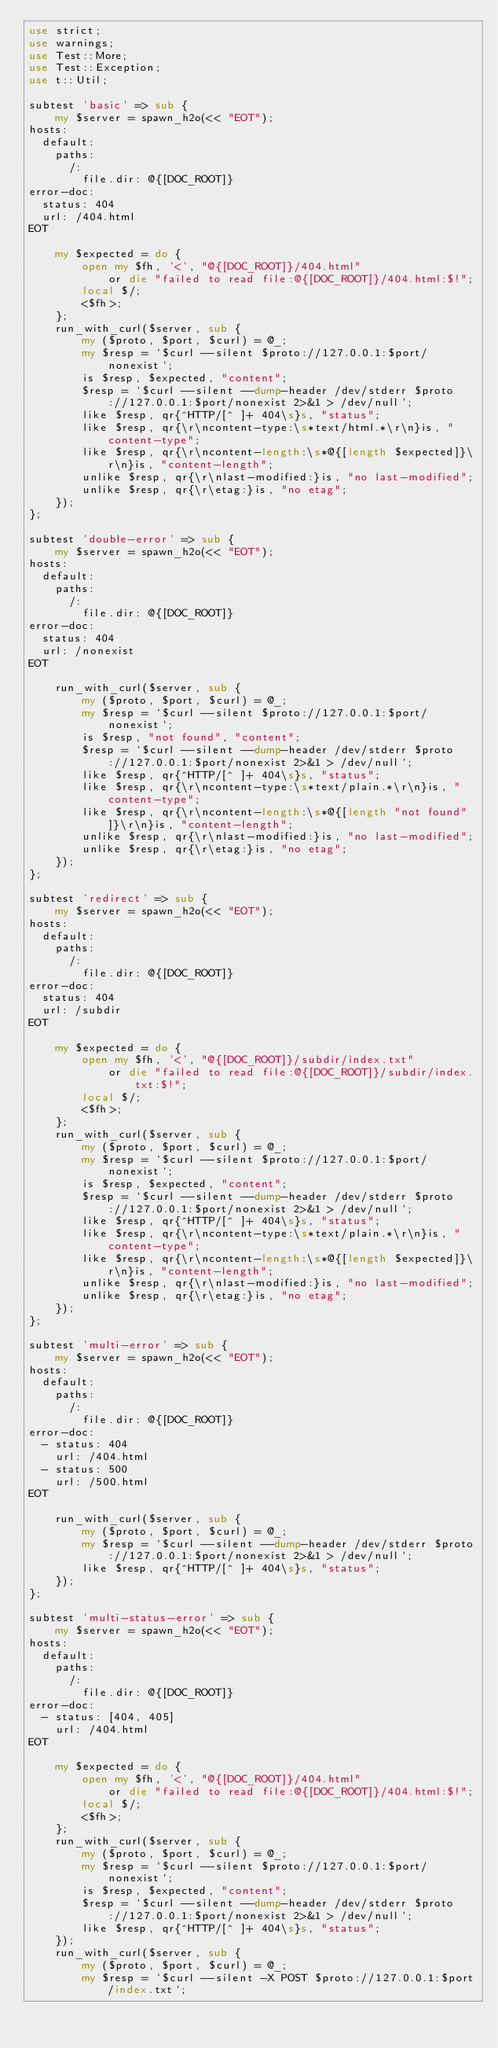<code> <loc_0><loc_0><loc_500><loc_500><_Perl_>use strict;
use warnings;
use Test::More;
use Test::Exception;
use t::Util;

subtest 'basic' => sub {
    my $server = spawn_h2o(<< "EOT");
hosts:
  default:
    paths:
      /:
        file.dir: @{[DOC_ROOT]}
error-doc:
  status: 404
  url: /404.html
EOT

    my $expected = do {
        open my $fh, '<', "@{[DOC_ROOT]}/404.html"
            or die "failed to read file:@{[DOC_ROOT]}/404.html:$!";
        local $/;
        <$fh>;
    };
    run_with_curl($server, sub {
        my ($proto, $port, $curl) = @_;
        my $resp = `$curl --silent $proto://127.0.0.1:$port/nonexist`;
        is $resp, $expected, "content";
        $resp = `$curl --silent --dump-header /dev/stderr $proto://127.0.0.1:$port/nonexist 2>&1 > /dev/null`;
        like $resp, qr{^HTTP/[^ ]+ 404\s}s, "status";
        like $resp, qr{\r\ncontent-type:\s*text/html.*\r\n}is, "content-type";
        like $resp, qr{\r\ncontent-length:\s*@{[length $expected]}\r\n}is, "content-length";
        unlike $resp, qr{\r\nlast-modified:}is, "no last-modified";
        unlike $resp, qr{\r\etag:}is, "no etag";
    });
};

subtest 'double-error' => sub {
    my $server = spawn_h2o(<< "EOT");
hosts:
  default:
    paths:
      /:
        file.dir: @{[DOC_ROOT]}
error-doc:
  status: 404
  url: /nonexist
EOT

    run_with_curl($server, sub {
        my ($proto, $port, $curl) = @_;
        my $resp = `$curl --silent $proto://127.0.0.1:$port/nonexist`;
        is $resp, "not found", "content";
        $resp = `$curl --silent --dump-header /dev/stderr $proto://127.0.0.1:$port/nonexist 2>&1 > /dev/null`;
        like $resp, qr{^HTTP/[^ ]+ 404\s}s, "status";
        like $resp, qr{\r\ncontent-type:\s*text/plain.*\r\n}is, "content-type";
        like $resp, qr{\r\ncontent-length:\s*@{[length "not found"]}\r\n}is, "content-length";
        unlike $resp, qr{\r\nlast-modified:}is, "no last-modified";
        unlike $resp, qr{\r\etag:}is, "no etag";
    });
};

subtest 'redirect' => sub {
    my $server = spawn_h2o(<< "EOT");
hosts:
  default:
    paths:
      /:
        file.dir: @{[DOC_ROOT]}
error-doc:
  status: 404
  url: /subdir
EOT

    my $expected = do {
        open my $fh, '<', "@{[DOC_ROOT]}/subdir/index.txt"
            or die "failed to read file:@{[DOC_ROOT]}/subdir/index.txt:$!";
        local $/;
        <$fh>;
    };
    run_with_curl($server, sub {
        my ($proto, $port, $curl) = @_;
        my $resp = `$curl --silent $proto://127.0.0.1:$port/nonexist`;
        is $resp, $expected, "content";
        $resp = `$curl --silent --dump-header /dev/stderr $proto://127.0.0.1:$port/nonexist 2>&1 > /dev/null`;
        like $resp, qr{^HTTP/[^ ]+ 404\s}s, "status";
        like $resp, qr{\r\ncontent-type:\s*text/plain.*\r\n}is, "content-type";
        like $resp, qr{\r\ncontent-length:\s*@{[length $expected]}\r\n}is, "content-length";
        unlike $resp, qr{\r\nlast-modified:}is, "no last-modified";
        unlike $resp, qr{\r\etag:}is, "no etag";
    });
};

subtest 'multi-error' => sub {
    my $server = spawn_h2o(<< "EOT");
hosts:
  default:
    paths:
      /:
        file.dir: @{[DOC_ROOT]}
error-doc:
  - status: 404
    url: /404.html
  - status: 500
    url: /500.html
EOT

    run_with_curl($server, sub {
        my ($proto, $port, $curl) = @_;
        my $resp = `$curl --silent --dump-header /dev/stderr $proto://127.0.0.1:$port/nonexist 2>&1 > /dev/null`;
        like $resp, qr{^HTTP/[^ ]+ 404\s}s, "status";
    });
};

subtest 'multi-status-error' => sub {
    my $server = spawn_h2o(<< "EOT");
hosts:
  default:
    paths:
      /:
        file.dir: @{[DOC_ROOT]}
error-doc:
  - status: [404, 405]
    url: /404.html
EOT

    my $expected = do {
        open my $fh, '<', "@{[DOC_ROOT]}/404.html"
            or die "failed to read file:@{[DOC_ROOT]}/404.html:$!";
        local $/;
        <$fh>;
    };
    run_with_curl($server, sub {
        my ($proto, $port, $curl) = @_;
        my $resp = `$curl --silent $proto://127.0.0.1:$port/nonexist`;
        is $resp, $expected, "content";
        $resp = `$curl --silent --dump-header /dev/stderr $proto://127.0.0.1:$port/nonexist 2>&1 > /dev/null`;
        like $resp, qr{^HTTP/[^ ]+ 404\s}s, "status";
    });
    run_with_curl($server, sub {
        my ($proto, $port, $curl) = @_;
        my $resp = `$curl --silent -X POST $proto://127.0.0.1:$port/index.txt`;</code> 